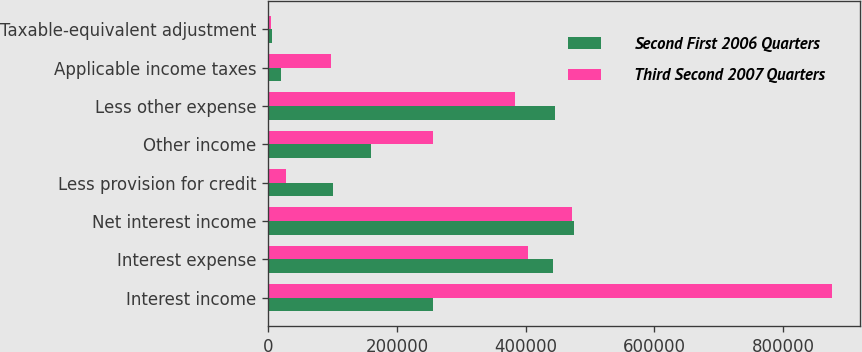Convert chart to OTSL. <chart><loc_0><loc_0><loc_500><loc_500><stacked_bar_chart><ecel><fcel>Interest income<fcel>Interest expense<fcel>Net interest income<fcel>Less provision for credit<fcel>Other income<fcel>Less other expense<fcel>Applicable income taxes<fcel>Taxable-equivalent adjustment<nl><fcel>Second First 2006 Quarters<fcel>256417<fcel>442364<fcel>475836<fcel>101000<fcel>160490<fcel>445473<fcel>19297<fcel>5626<nl><fcel>Third Second 2007 Quarters<fcel>876197<fcel>404356<fcel>471841<fcel>28000<fcel>256417<fcel>383810<fcel>97996<fcel>5123<nl></chart> 